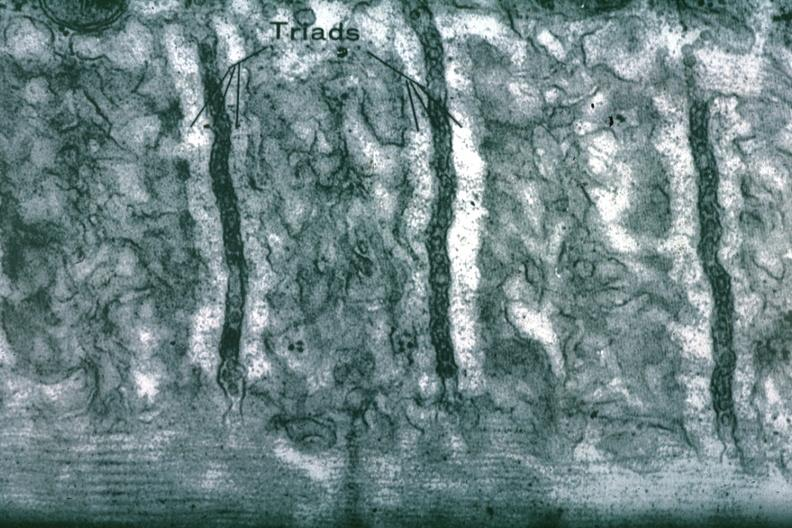s cardiovascular present?
Answer the question using a single word or phrase. Yes 